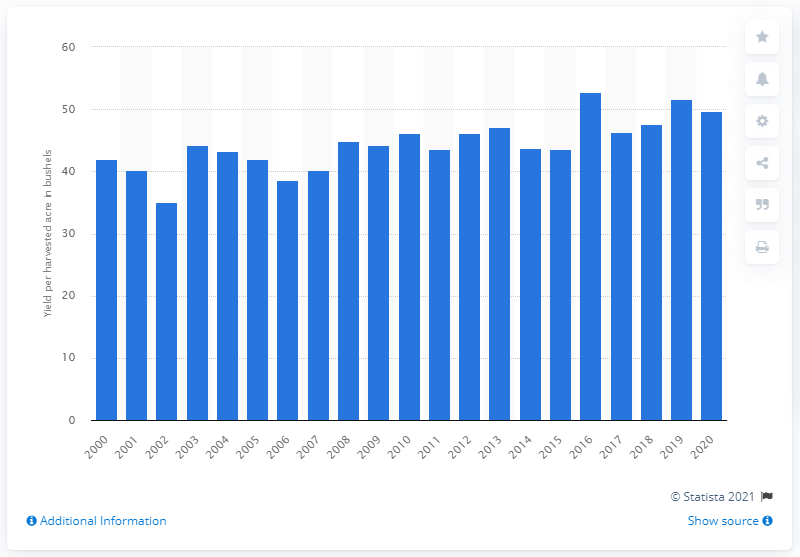Mention a couple of crucial points in this snapshot. In 2020, the U.S. produced an average of 49.7 wheat crop per harvested acre. 